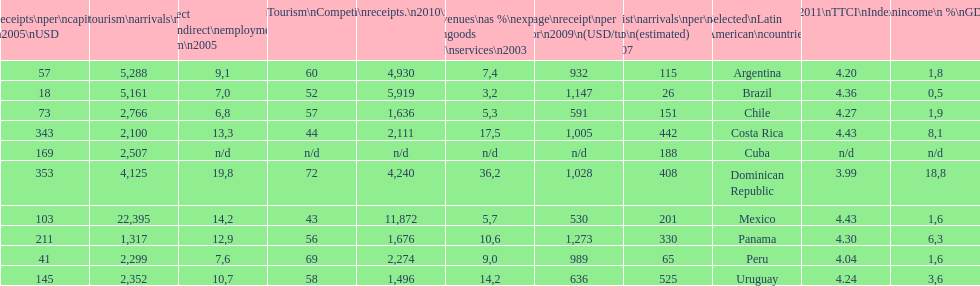What country had the most receipts per capita in 2005? Dominican Republic. 